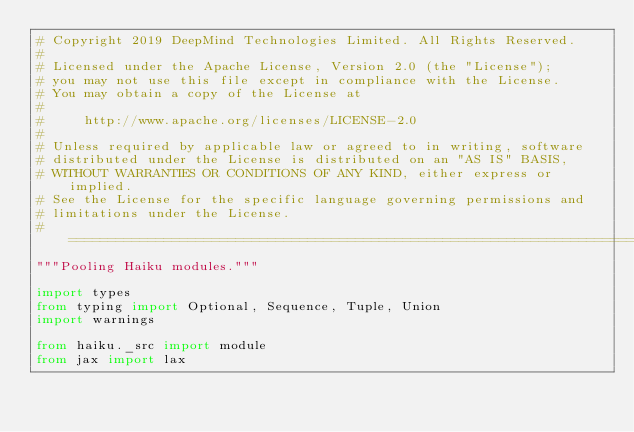Convert code to text. <code><loc_0><loc_0><loc_500><loc_500><_Python_># Copyright 2019 DeepMind Technologies Limited. All Rights Reserved.
#
# Licensed under the Apache License, Version 2.0 (the "License");
# you may not use this file except in compliance with the License.
# You may obtain a copy of the License at
#
#     http://www.apache.org/licenses/LICENSE-2.0
#
# Unless required by applicable law or agreed to in writing, software
# distributed under the License is distributed on an "AS IS" BASIS,
# WITHOUT WARRANTIES OR CONDITIONS OF ANY KIND, either express or implied.
# See the License for the specific language governing permissions and
# limitations under the License.
# ==============================================================================
"""Pooling Haiku modules."""

import types
from typing import Optional, Sequence, Tuple, Union
import warnings

from haiku._src import module
from jax import lax</code> 